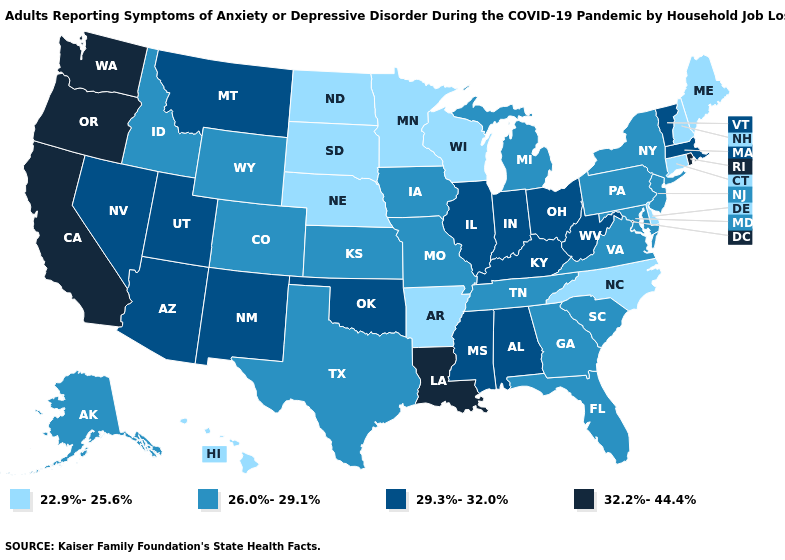What is the value of Connecticut?
Write a very short answer. 22.9%-25.6%. What is the value of Maine?
Answer briefly. 22.9%-25.6%. Name the states that have a value in the range 26.0%-29.1%?
Be succinct. Alaska, Colorado, Florida, Georgia, Idaho, Iowa, Kansas, Maryland, Michigan, Missouri, New Jersey, New York, Pennsylvania, South Carolina, Tennessee, Texas, Virginia, Wyoming. Does Oregon have the highest value in the USA?
Give a very brief answer. Yes. Name the states that have a value in the range 32.2%-44.4%?
Write a very short answer. California, Louisiana, Oregon, Rhode Island, Washington. Name the states that have a value in the range 26.0%-29.1%?
Give a very brief answer. Alaska, Colorado, Florida, Georgia, Idaho, Iowa, Kansas, Maryland, Michigan, Missouri, New Jersey, New York, Pennsylvania, South Carolina, Tennessee, Texas, Virginia, Wyoming. Does Washington have a lower value than Nebraska?
Concise answer only. No. Name the states that have a value in the range 29.3%-32.0%?
Concise answer only. Alabama, Arizona, Illinois, Indiana, Kentucky, Massachusetts, Mississippi, Montana, Nevada, New Mexico, Ohio, Oklahoma, Utah, Vermont, West Virginia. Among the states that border Pennsylvania , does Delaware have the lowest value?
Be succinct. Yes. What is the value of Colorado?
Concise answer only. 26.0%-29.1%. Among the states that border Arizona , does Nevada have the highest value?
Quick response, please. No. Does Wisconsin have a lower value than Maine?
Answer briefly. No. What is the value of Connecticut?
Short answer required. 22.9%-25.6%. Which states have the highest value in the USA?
Short answer required. California, Louisiana, Oregon, Rhode Island, Washington. What is the highest value in states that border West Virginia?
Short answer required. 29.3%-32.0%. 